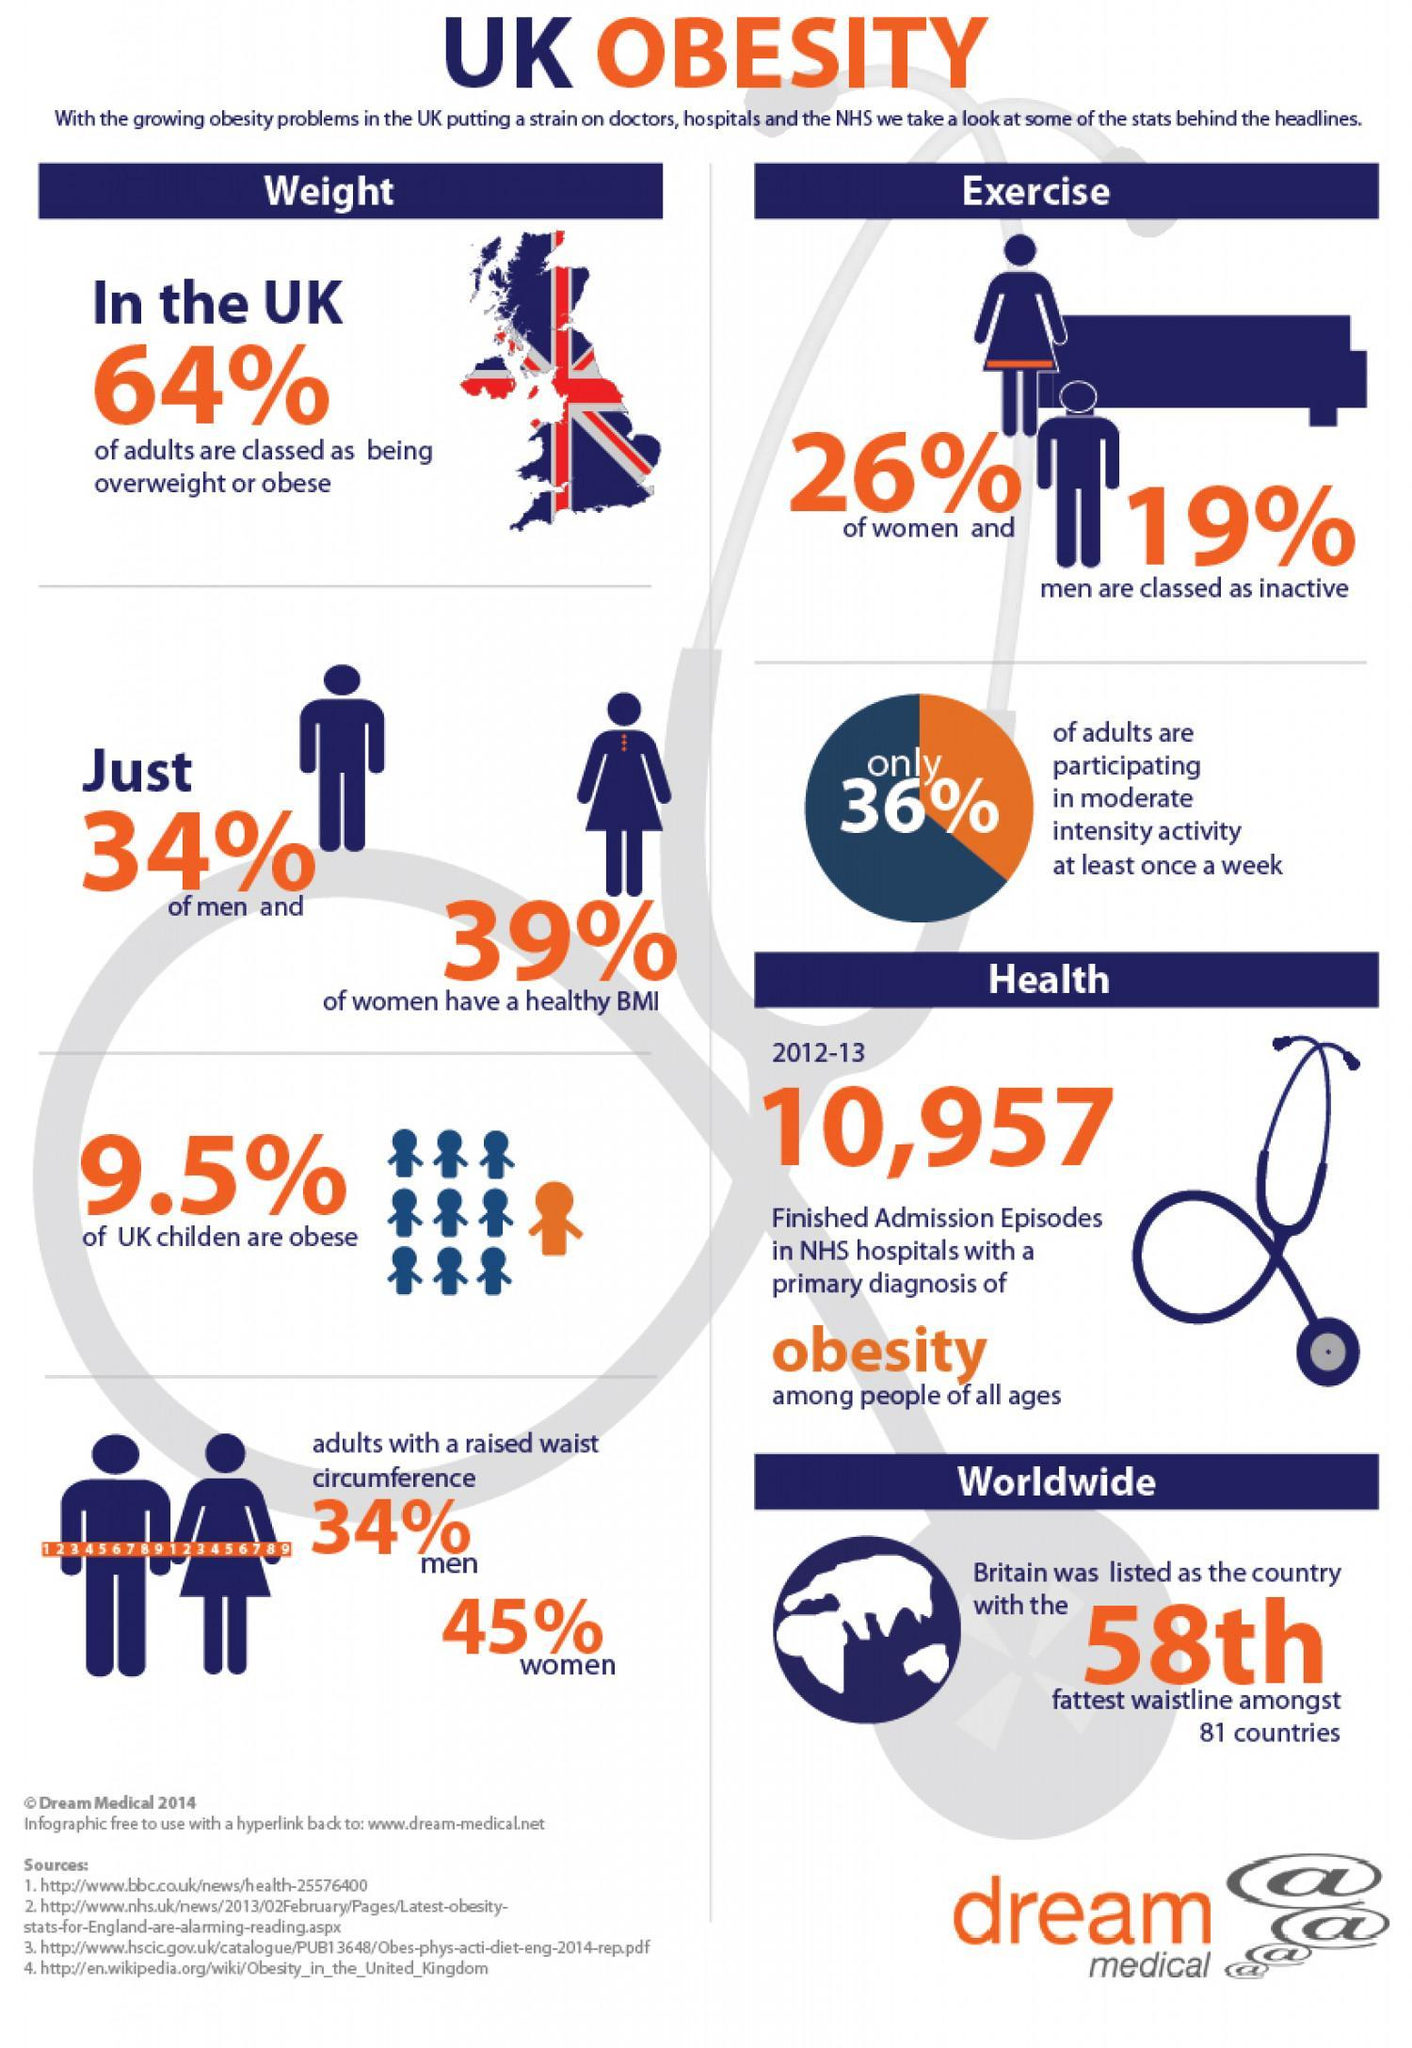How many more women are classed as inactive than men?
Answer the question with a short phrase. 7% How much more do the women contribute to the total adults with a raised waist circumference than men? 11% 